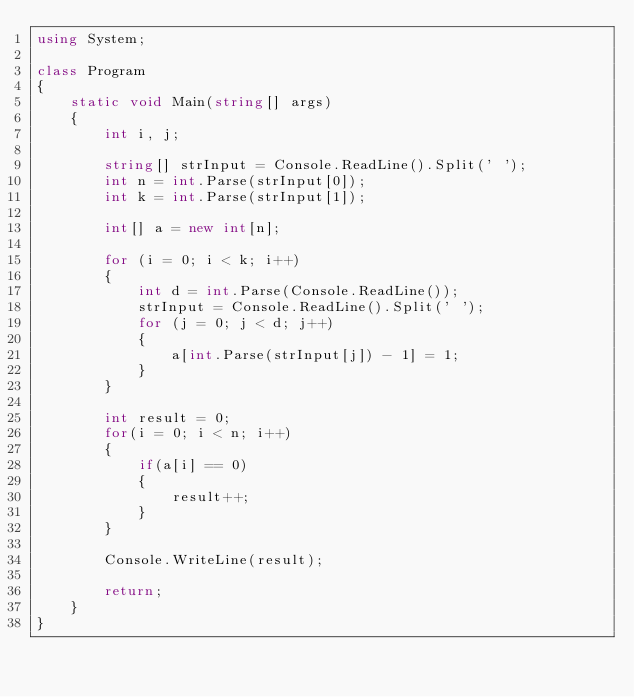Convert code to text. <code><loc_0><loc_0><loc_500><loc_500><_C#_>using System;

class Program
{
	static void Main(string[] args)
	{
		int i, j;

		string[] strInput = Console.ReadLine().Split(' ');
		int n = int.Parse(strInput[0]);
		int k = int.Parse(strInput[1]);

		int[] a = new int[n];

		for (i = 0; i < k; i++)
		{
			int d = int.Parse(Console.ReadLine());
			strInput = Console.ReadLine().Split(' ');
			for (j = 0; j < d; j++)
			{
				a[int.Parse(strInput[j]) - 1] = 1;
			}
		}

		int result = 0;
		for(i = 0; i < n; i++)
		{
			if(a[i] == 0)
			{
				result++;
			}
		}

		Console.WriteLine(result);

		return;
	}
}</code> 